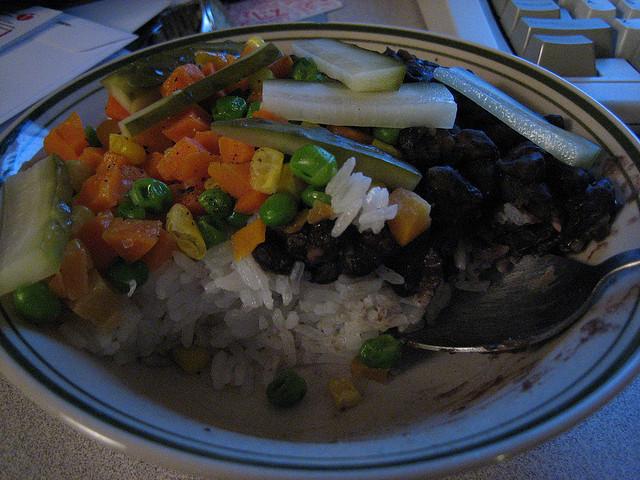Are these veggies?
Quick response, please. Yes. Is this a healthy meal?
Write a very short answer. Yes. Is there a napkin?
Be succinct. No. Are there any peas on the plate?
Give a very brief answer. Yes. What vegetables are in the pot?
Concise answer only. Carrots, peas, corn, cucumber. What silverware is on the plate?
Be succinct. Spoon. Is this a salad?
Short answer required. No. What is the black thing on the plate?
Be succinct. Beans. 